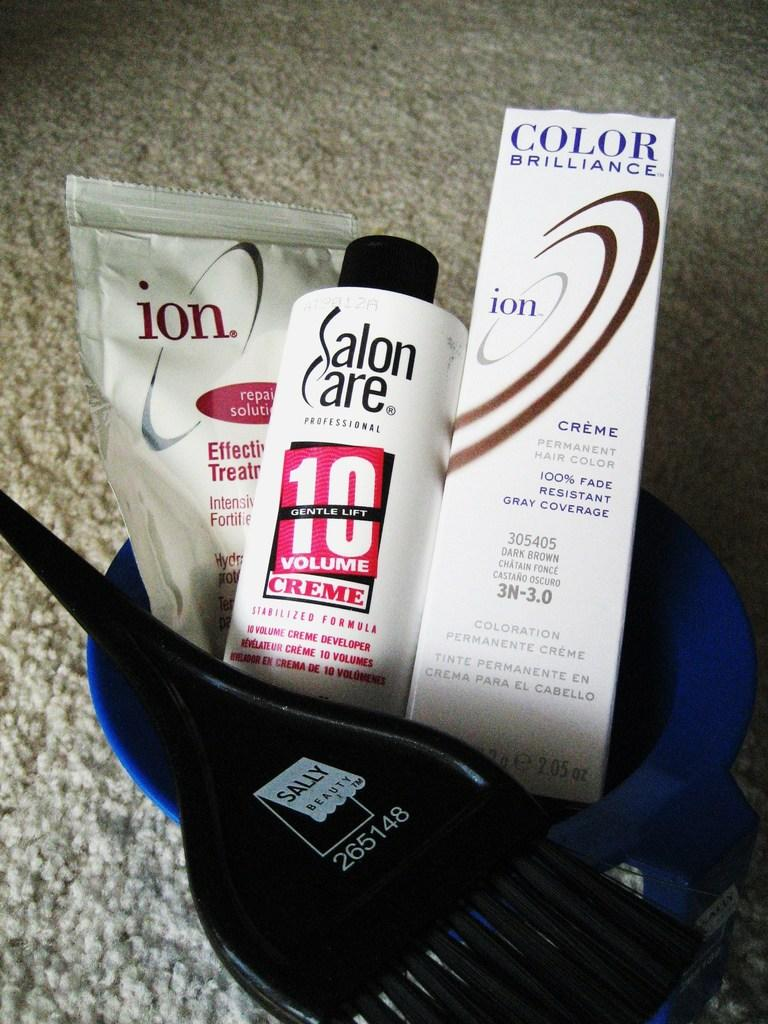<image>
Summarize the visual content of the image. A bucket of hair care products with salon care and a sally brush 